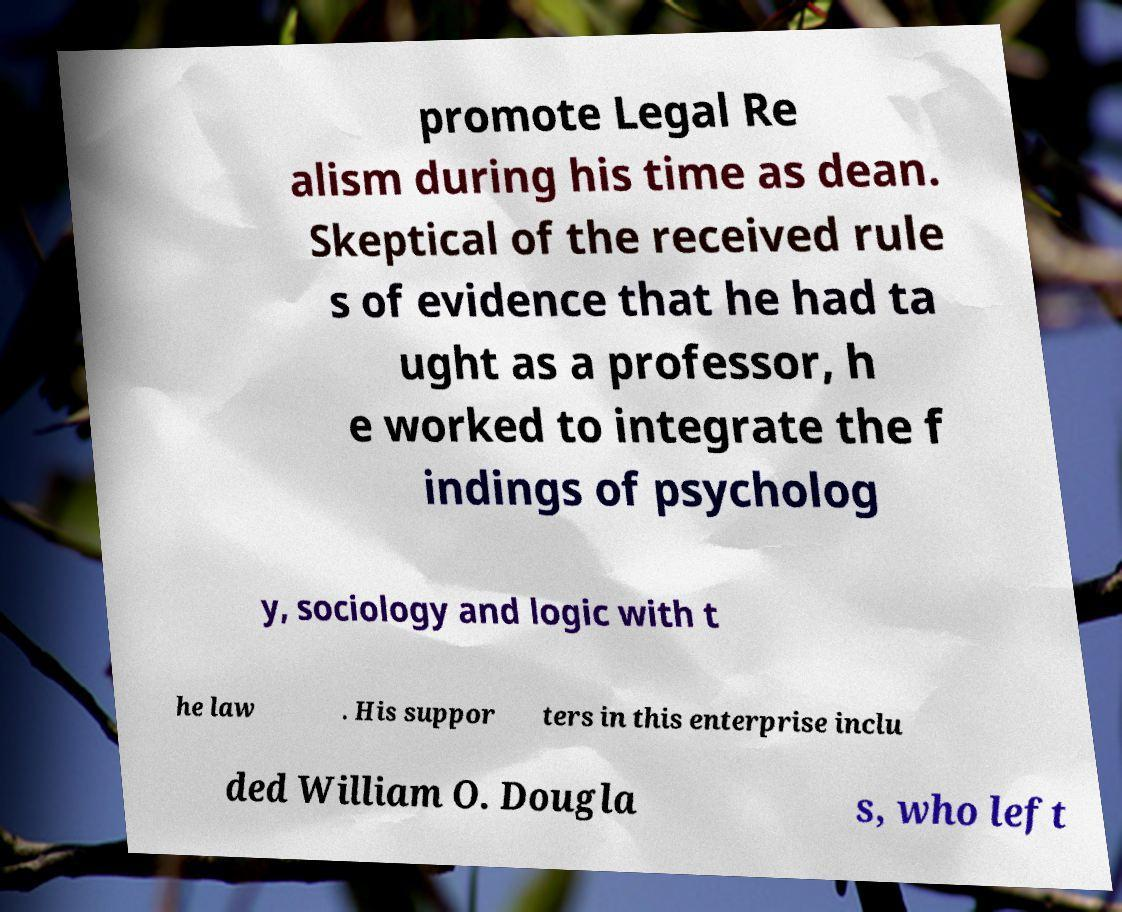Could you extract and type out the text from this image? promote Legal Re alism during his time as dean. Skeptical of the received rule s of evidence that he had ta ught as a professor, h e worked to integrate the f indings of psycholog y, sociology and logic with t he law . His suppor ters in this enterprise inclu ded William O. Dougla s, who left 